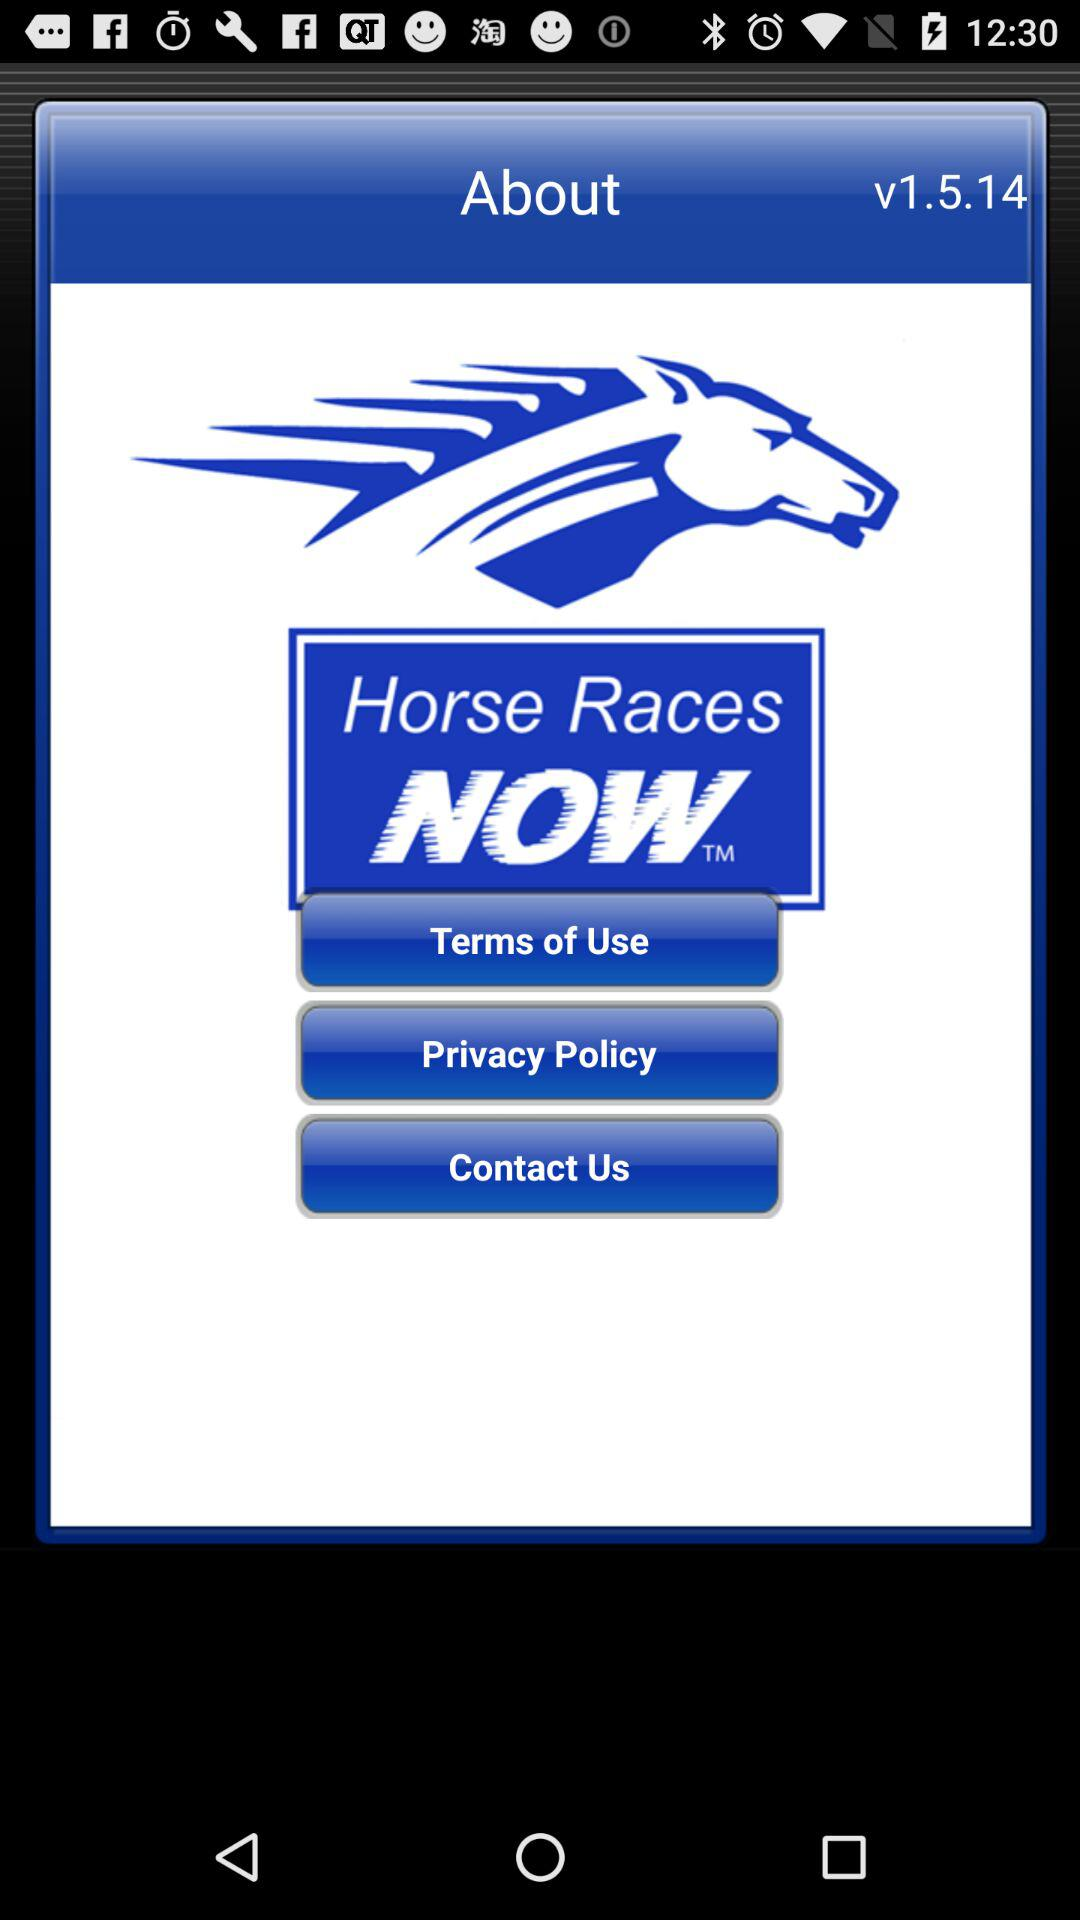What is the application name? The application name is "Horse Races NOW". 